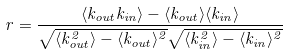Convert formula to latex. <formula><loc_0><loc_0><loc_500><loc_500>r = \frac { \langle k _ { o u t } k _ { i n } \rangle - \langle k _ { o u t } \rangle \langle k _ { i n } \rangle } { \sqrt { \langle k ^ { 2 } _ { o u t } \rangle - \langle k _ { o u t } \rangle ^ { 2 } } \sqrt { \langle k ^ { 2 } _ { i n } \rangle - \langle k _ { i n } \rangle ^ { 2 } } }</formula> 